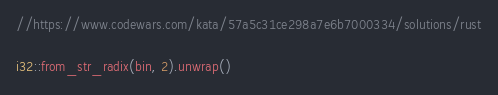<code> <loc_0><loc_0><loc_500><loc_500><_Rust_>//https://www.codewars.com/kata/57a5c31ce298a7e6b7000334/solutions/rust

i32::from_str_radix(bin, 2).unwrap()
</code> 